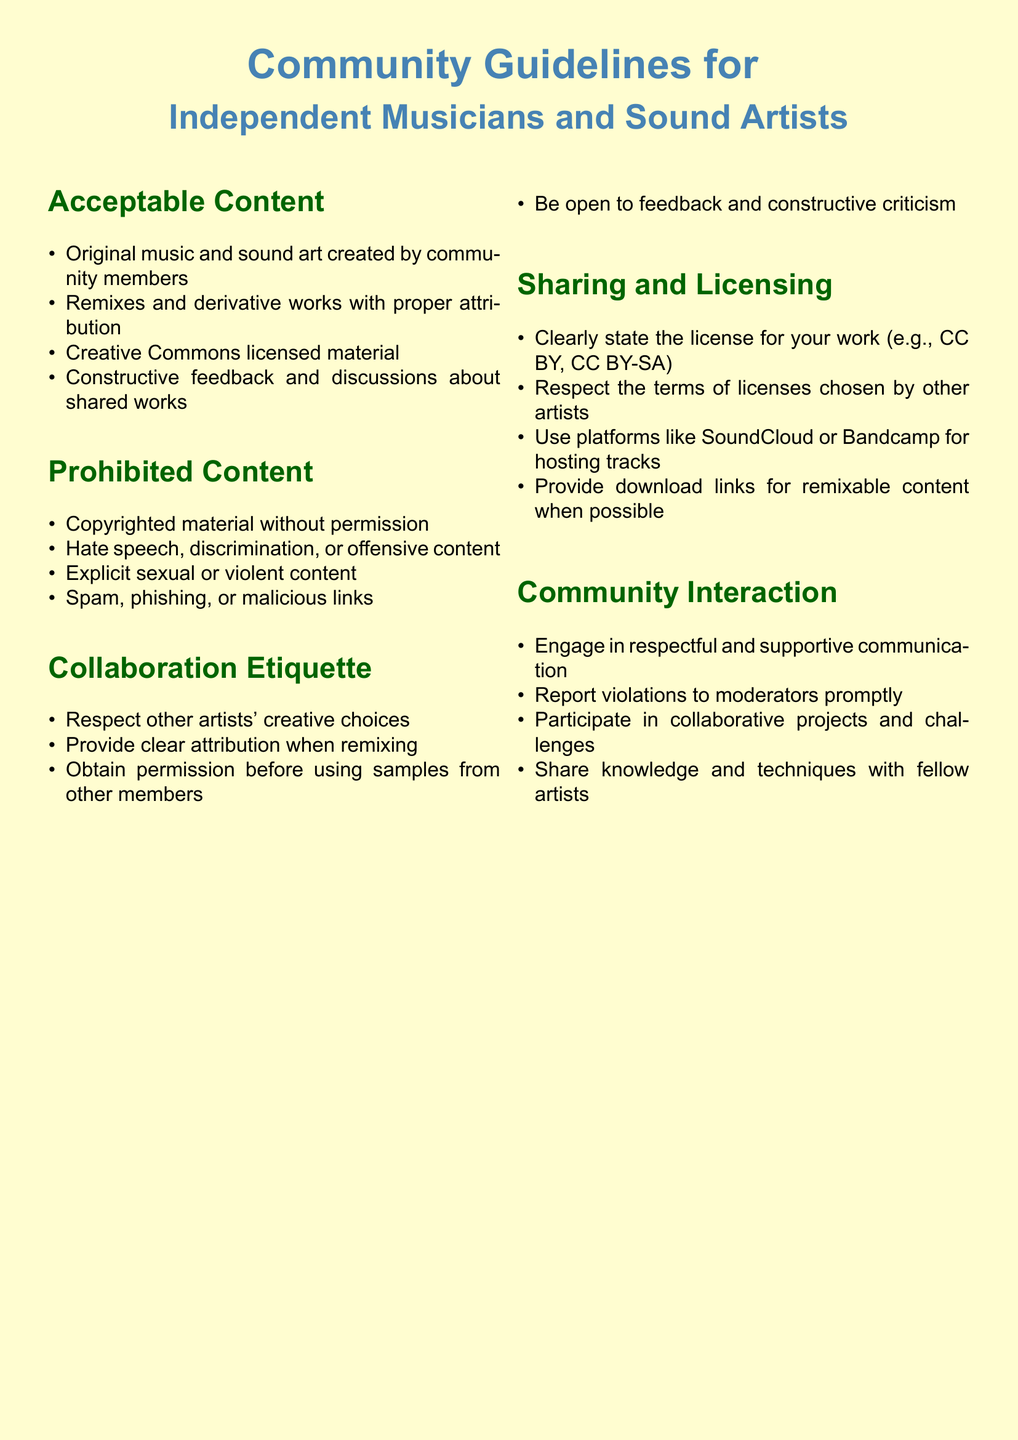what is the title of the document? The title is located at the top of the document, indicating the main subject it covers.
Answer: Community Guidelines for Independent Musicians and Sound Artists how many categories are listed in the document? The document contains multiple sections, each covering different aspects of community guidelines.
Answer: Five what type of content is explicitly prohibited? This information can be found in the section detailing unacceptable behavior and content standards.
Answer: Copyrighted material without permission what should you do before using samples from other members? The guideline suggests a specific action regarding the use of others' work, which is important for respectful collaboration.
Answer: Obtain permission which license must you clearly state for your work? This is outlined in the section about sharing and licensing, specifying how to properly share original content.
Answer: CC BY, CC BY-SA what is encouraged in community interaction? The document mentions a specific form of communication that fosters positive relationships among members.
Answer: Respectful and supportive communication how should you provide feedback on shared works? This is indicated in the guidelines on collaboration etiquette, reflecting the community's values for constructive criticism.
Answer: Constructive feedback which platforms are recommended for hosting tracks? The document specifies certain platforms, providing options for where members can share their music effectively.
Answer: SoundCloud or Bandcamp 